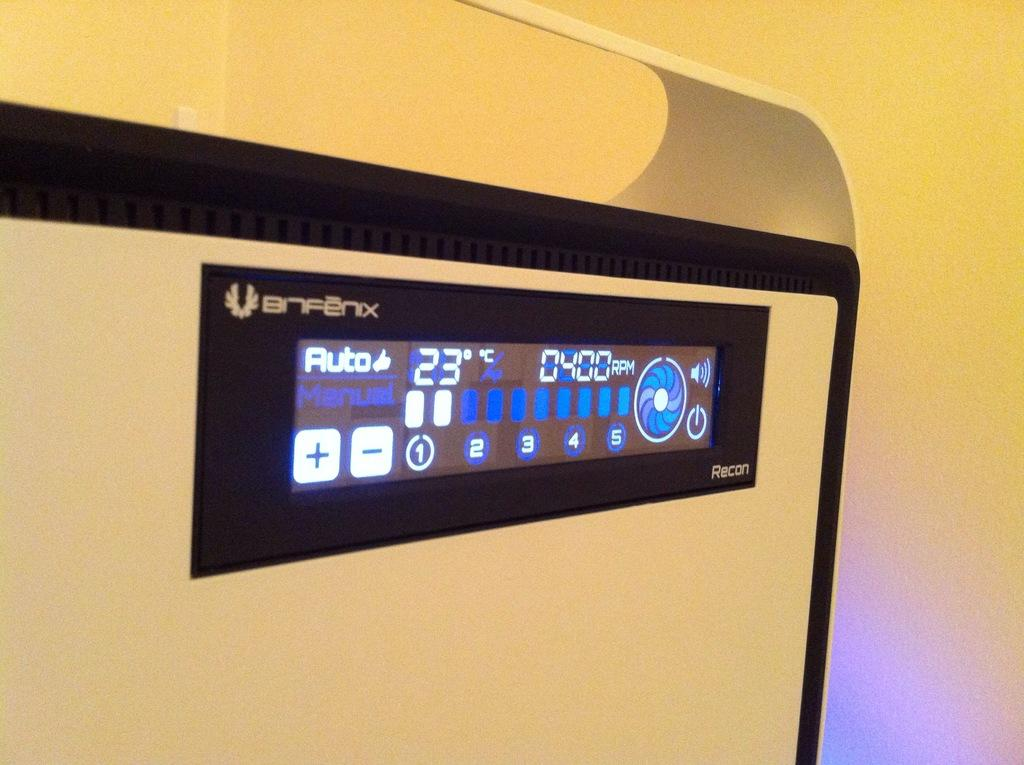<image>
Give a short and clear explanation of the subsequent image. An electronic panel is set to Auto and shows it is 4:00 PM. 